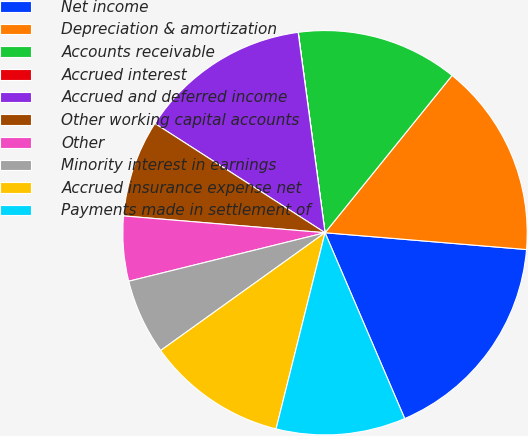<chart> <loc_0><loc_0><loc_500><loc_500><pie_chart><fcel>Net income<fcel>Depreciation & amortization<fcel>Accounts receivable<fcel>Accrued interest<fcel>Accrued and deferred income<fcel>Other working capital accounts<fcel>Other<fcel>Minority interest in earnings<fcel>Accrued insurance expense net<fcel>Payments made in settlement of<nl><fcel>17.23%<fcel>15.51%<fcel>12.93%<fcel>0.01%<fcel>13.79%<fcel>7.76%<fcel>5.18%<fcel>6.04%<fcel>11.21%<fcel>10.34%<nl></chart> 